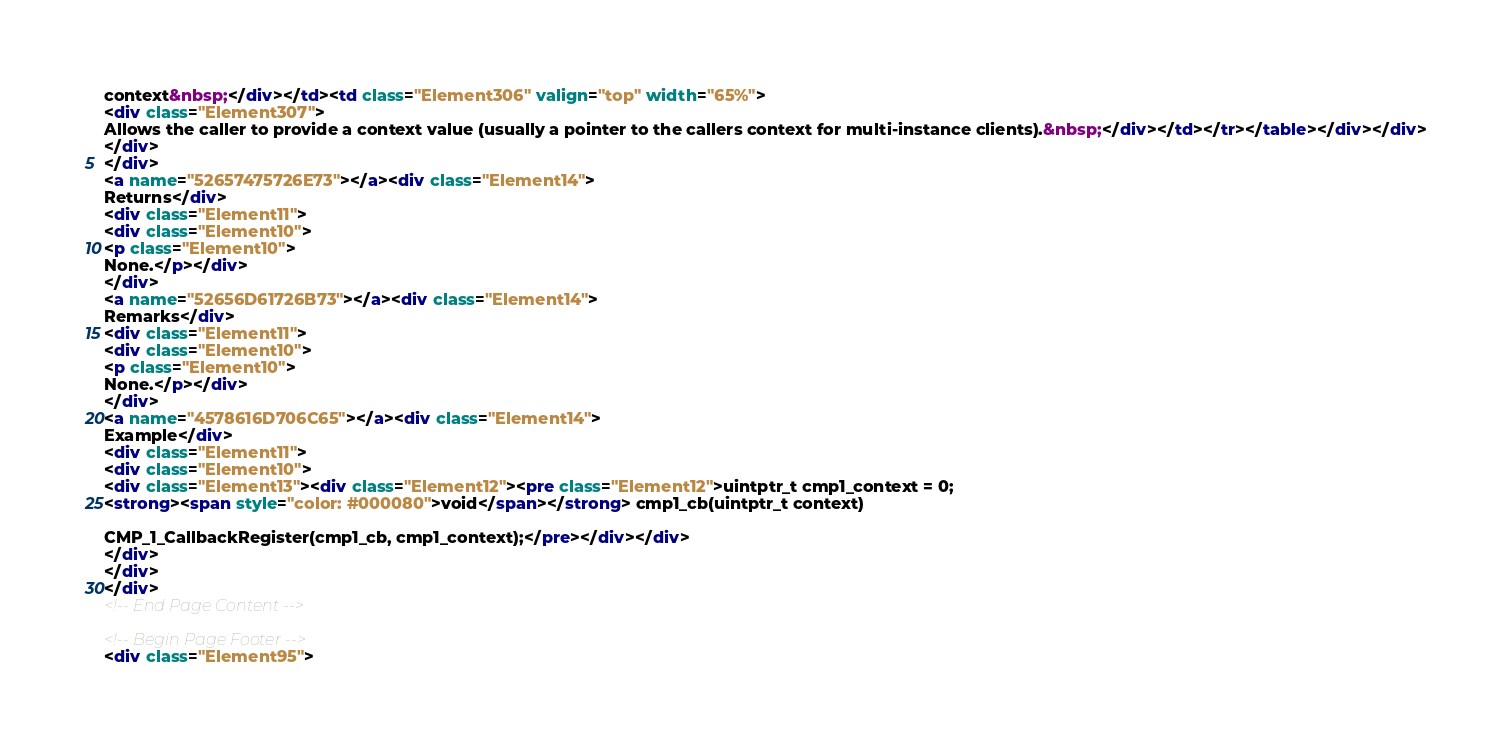<code> <loc_0><loc_0><loc_500><loc_500><_HTML_>context&nbsp;</div></td><td class="Element306" valign="top" width="65%">
<div class="Element307">
Allows the caller to provide a context value (usually a pointer to the callers context for multi-instance clients).&nbsp;</div></td></tr></table></div></div>
</div>
</div>
<a name="52657475726E73"></a><div class="Element14">
Returns</div>
<div class="Element11">
<div class="Element10">
<p class="Element10">
None.</p></div>
</div>
<a name="52656D61726B73"></a><div class="Element14">
Remarks</div>
<div class="Element11">
<div class="Element10">
<p class="Element10">
None.</p></div>
</div>
<a name="4578616D706C65"></a><div class="Element14">
Example</div>
<div class="Element11">
<div class="Element10">
<div class="Element13"><div class="Element12"><pre class="Element12">uintptr_t cmp1_context = 0;
<strong><span style="color: #000080">void</span></strong> cmp1_cb(uintptr_t context)

CMP_1_CallbackRegister(cmp1_cb, cmp1_context);</pre></div></div>
</div>
</div>
</div>
<!-- End Page Content -->

<!-- Begin Page Footer -->
<div class="Element95"></code> 